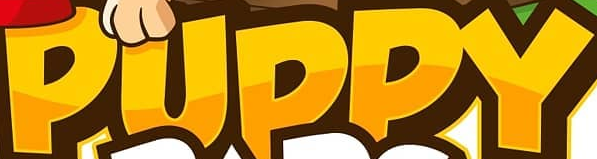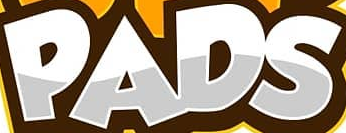What words can you see in these images in sequence, separated by a semicolon? PUPPY; PADS 